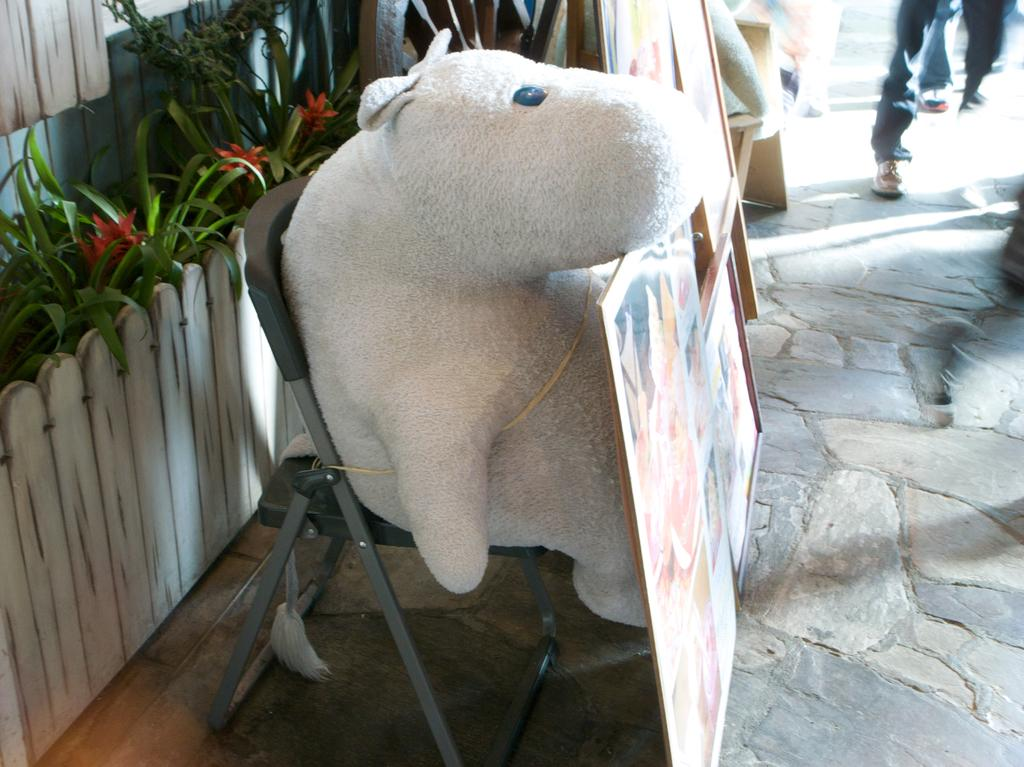What is placed on the chair in the image? There is a doll on a chair in the image. What can be seen in front of the plants in the image? There is fencing in front of the plants in the image. Can you describe the legs visible in the top right corner of the image? Person legs are visible in the top right corner of the image. Where is the drain located in the image? There is no drain present in the image. Can you see any toads in the image? There are no toads present in the image. 